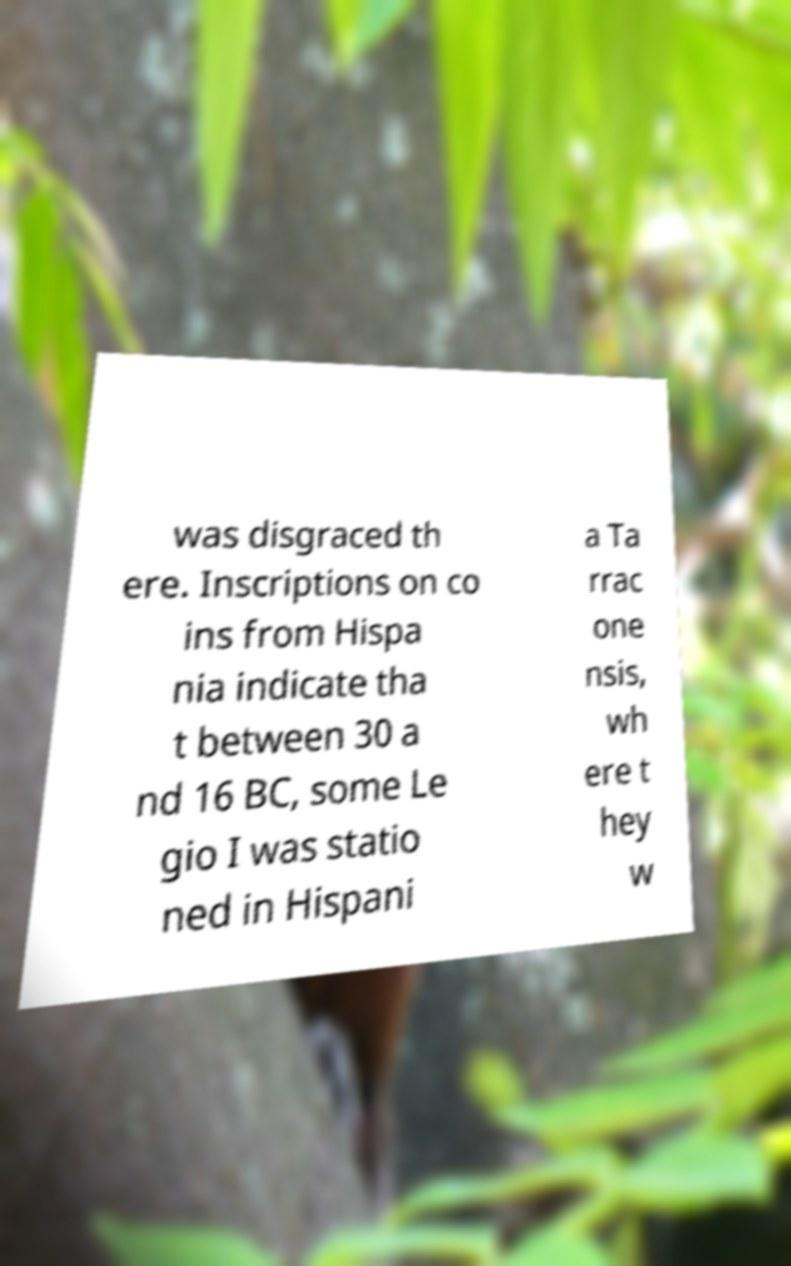Please identify and transcribe the text found in this image. was disgraced th ere. Inscriptions on co ins from Hispa nia indicate tha t between 30 a nd 16 BC, some Le gio I was statio ned in Hispani a Ta rrac one nsis, wh ere t hey w 